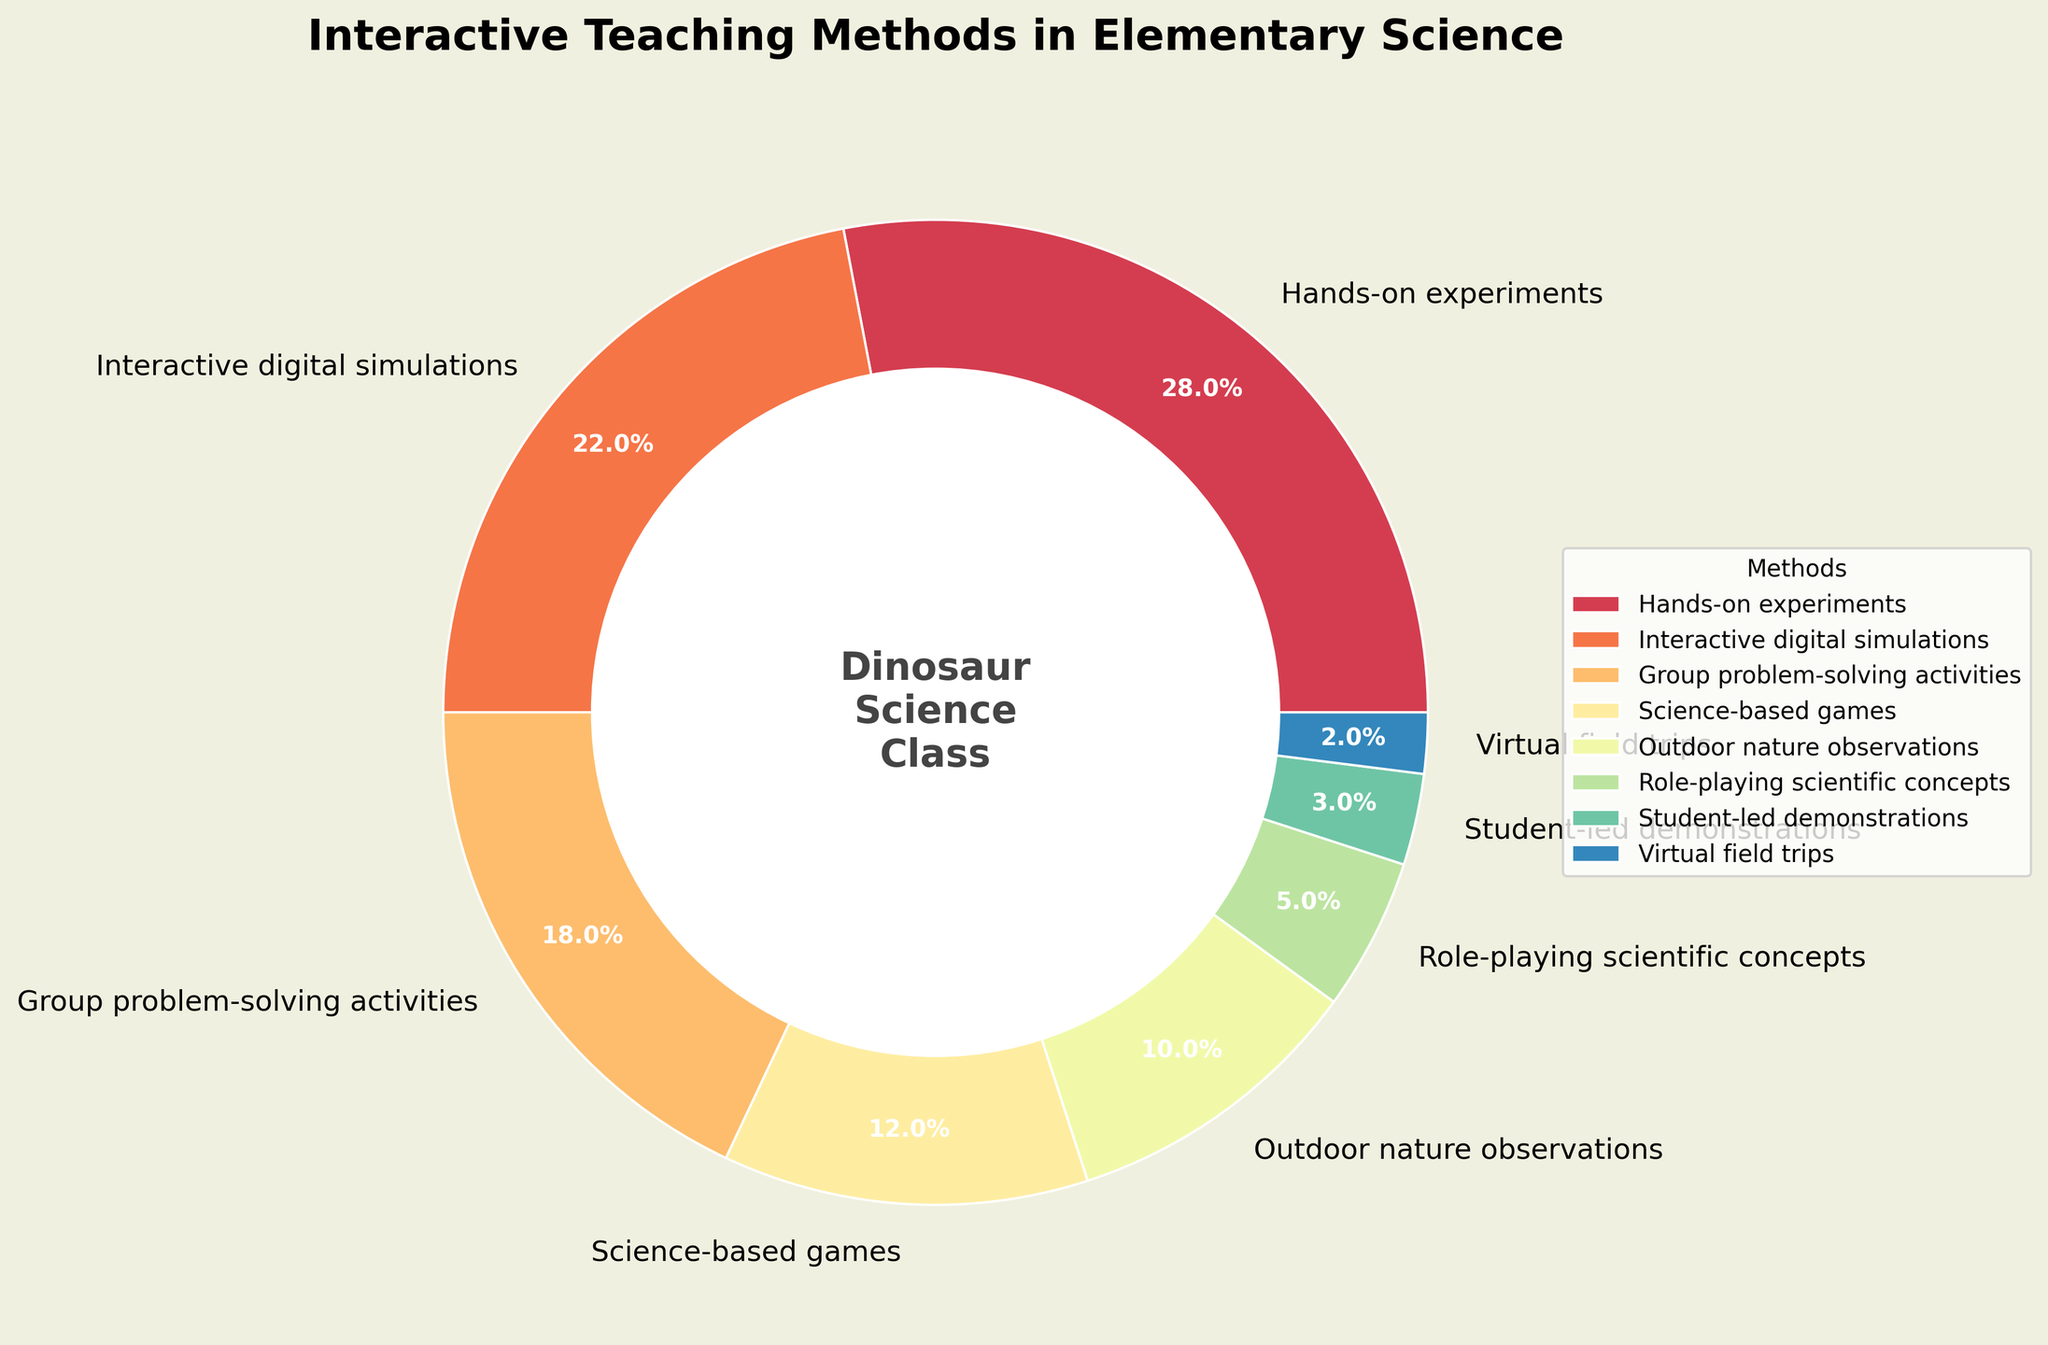What's the most common interactive teaching method used in elementary science? The pie chart shows different teaching methods with their percentages. The section with the highest percentage represents the most common method. "Hands-on experiments" has the largest section at 28%.
Answer: Hands-on experiments Which method is used less frequently: Role-playing scientific concepts or Virtual field trips? Compare their percentage values in the pie chart. Role-playing scientific concepts is 5% while Virtual field trips is 2%. The lower percentage indicates less frequent use.
Answer: Virtual field trips What is the combined percentage of Group problem-solving activities and Science-based games? Sum the percentage values for these methods: Group problem-solving activities (18%) + Science-based games (12%).
Answer: 30% How much more frequently are Interactive digital simulations used compared to Student-led demonstrations? Subtract the percentage of Student-led demonstrations from Interactive digital simulations. Interactive digital simulations (22%) - Student-led demonstrations (3%).
Answer: 19% Which teaching method occupies the greenish section of the pie chart? Identify the method associated with the greenish section by visually inspecting the pie chart and comparing segment colors. The greenish section corresponds to Outdoor nature observations (10%).
Answer: Outdoor nature observations What is the difference in percentage between the most and least common teaching methods? Subtract the percentage of the least common method from the most common method. Hands-on experiments (28%) - Virtual field trips (2%).
Answer: 26% What percentage of teaching methods are represented by activities outside the classroom? Sum the percentages of outdoor-specific methods. Outdoor nature observations (10%) + Virtual field trips (2%).
Answer: 12% Which two methods together make up more than half of the teaching methods used? Identify two methods whose combined percentages exceed 50%. Hands-on experiments (28%) + Interactive digital simulations (22%) sums up to 50%.
Answer: Hands-on experiments and Interactive digital simulations What color represents Science-based games? Identify the section color representing Science-based games by examining the pie chart. The color is based on visual identification from the chart.
Answer: Not directly answerable (Varies by visual interpretation) Between Hands-on experiments and Group problem-solving activities, which one has a larger representation, and by how much? Compare their percentages: Hands-on experiments (28%) and Group problem-solving activities (18%). Subtract the latter from the former: 28% - 18%.
Answer: Hands-on experiments by 10% 